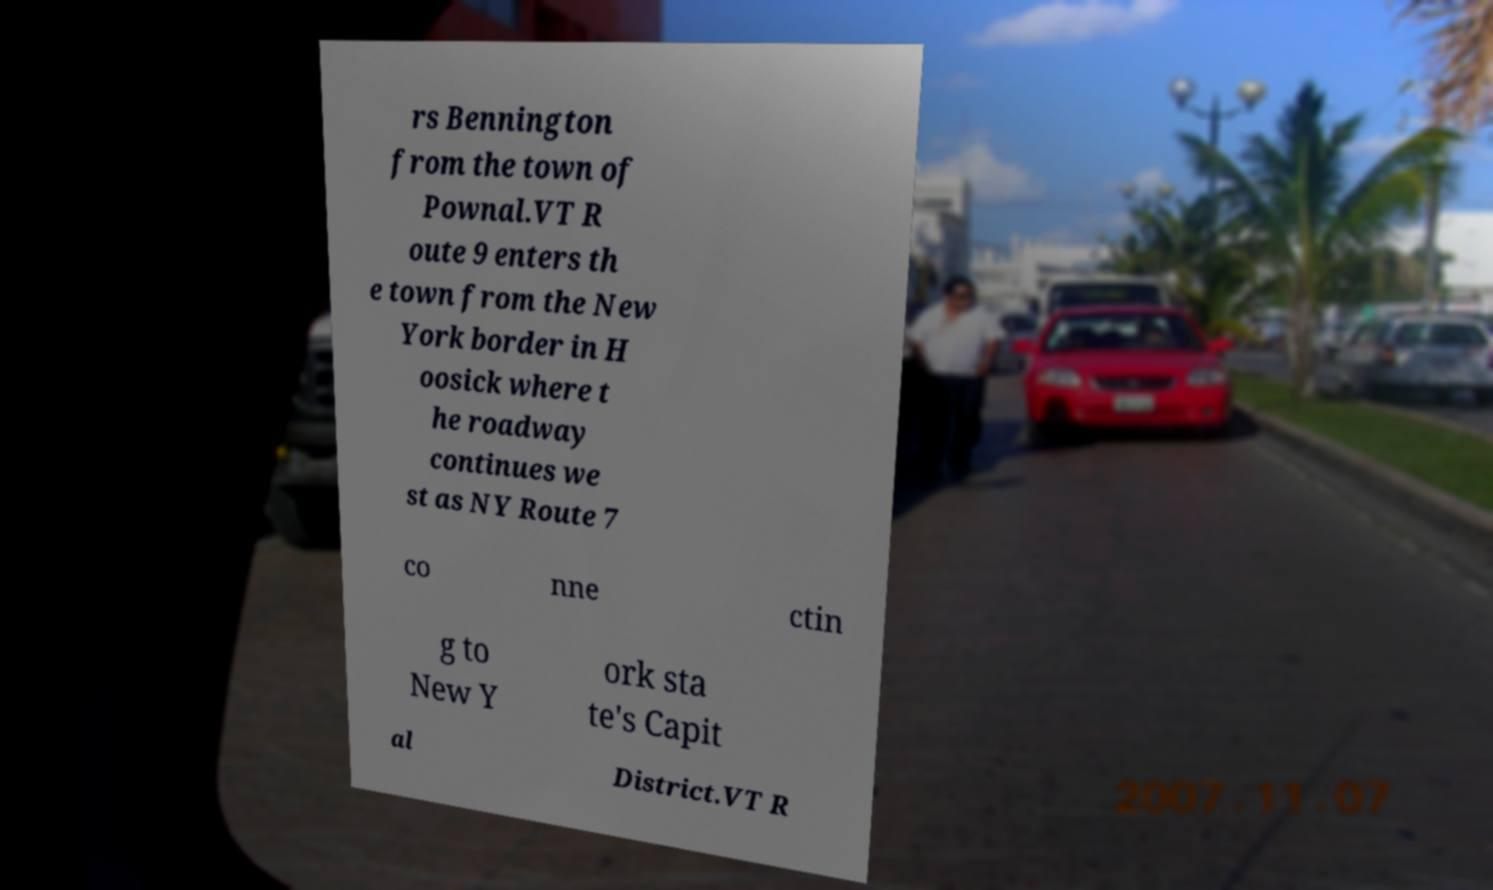Please read and relay the text visible in this image. What does it say? rs Bennington from the town of Pownal.VT R oute 9 enters th e town from the New York border in H oosick where t he roadway continues we st as NY Route 7 co nne ctin g to New Y ork sta te's Capit al District.VT R 